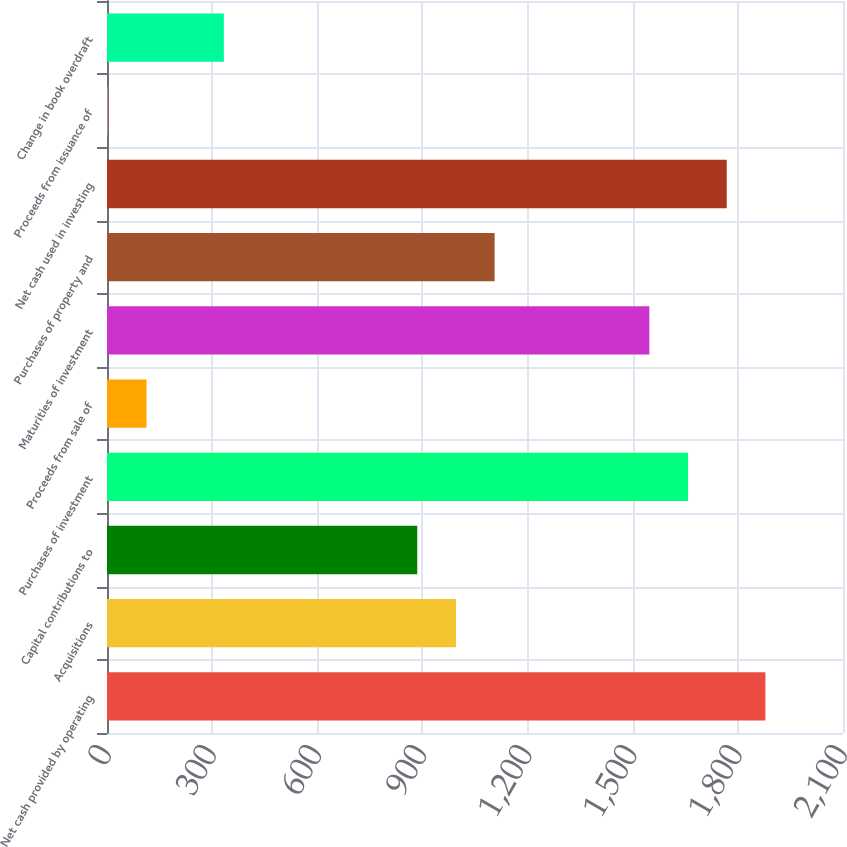Convert chart to OTSL. <chart><loc_0><loc_0><loc_500><loc_500><bar_chart><fcel>Net cash provided by operating<fcel>Acquisitions<fcel>Capital contributions to<fcel>Purchases of investment<fcel>Proceeds from sale of<fcel>Maturities of investment<fcel>Purchases of property and<fcel>Net cash used in investing<fcel>Proceeds from issuance of<fcel>Change in book overdraft<nl><fcel>1878.6<fcel>995.64<fcel>885.27<fcel>1657.86<fcel>112.68<fcel>1547.49<fcel>1106.01<fcel>1768.23<fcel>2.31<fcel>333.42<nl></chart> 